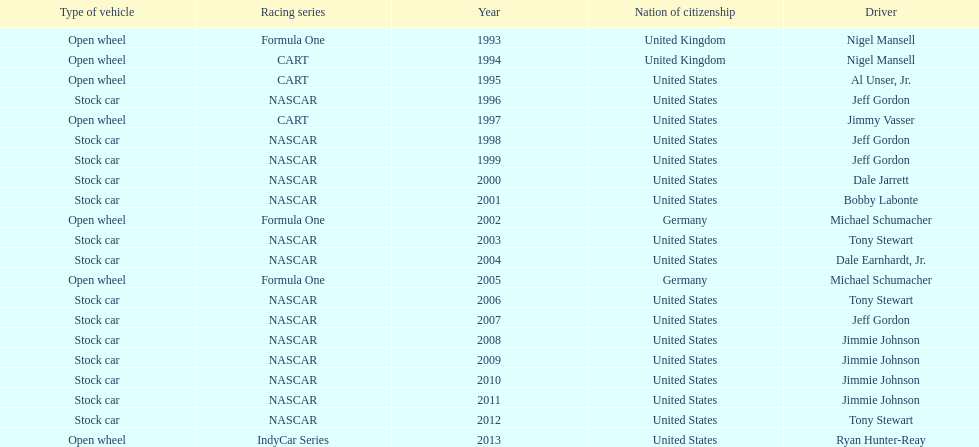Out of these drivers: nigel mansell, al unser, jr., michael schumacher, and jeff gordon, all but one has more than one espy award. who only has one espy award? Al Unser, Jr. 